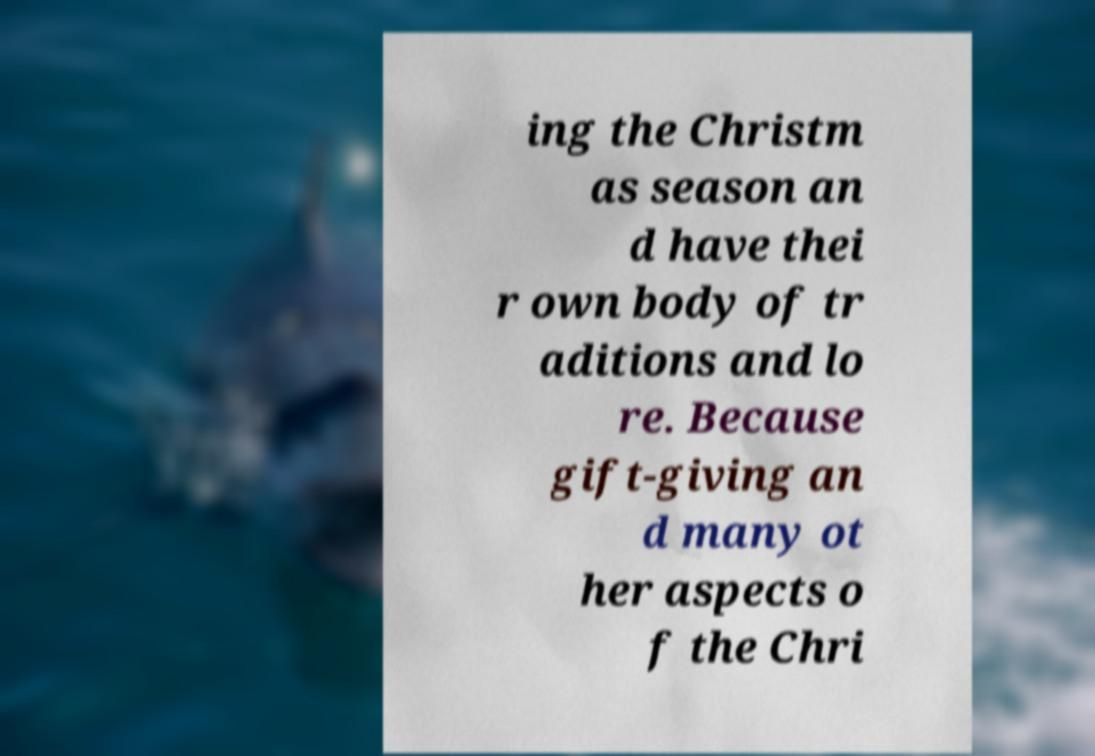Could you assist in decoding the text presented in this image and type it out clearly? ing the Christm as season an d have thei r own body of tr aditions and lo re. Because gift-giving an d many ot her aspects o f the Chri 